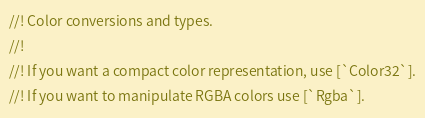Convert code to text. <code><loc_0><loc_0><loc_500><loc_500><_Rust_>//! Color conversions and types.
//!
//! If you want a compact color representation, use [`Color32`].
//! If you want to manipulate RGBA colors use [`Rgba`].</code> 